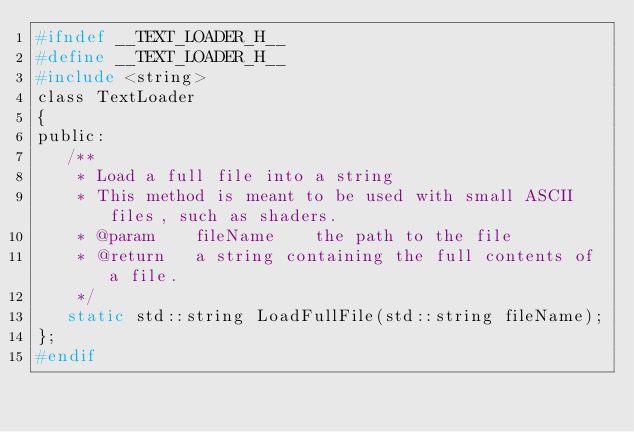Convert code to text. <code><loc_0><loc_0><loc_500><loc_500><_C_>#ifndef __TEXT_LOADER_H__
#define __TEXT_LOADER_H__
#include <string>
class TextLoader
{
public:
   /**
    * Load a full file into a string
    * This method is meant to be used with small ASCII files, such as shaders.
    * @param 	fileName	the path to the file
    * @return	a string containing the full contents of a file.
    */
   static std::string LoadFullFile(std::string fileName);
};
#endif</code> 